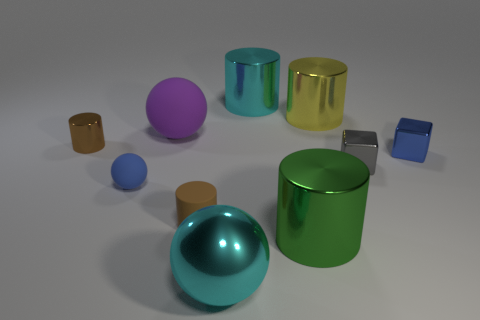What is the shape of the brown rubber object that is the same size as the blue rubber ball?
Give a very brief answer. Cylinder. Are there any brown things of the same shape as the big purple thing?
Give a very brief answer. No. What is the shape of the big thing left of the big cyan metallic object that is in front of the yellow metallic cylinder?
Your response must be concise. Sphere. What shape is the blue rubber thing?
Provide a succinct answer. Sphere. There is a large cyan object behind the metallic object that is in front of the large metallic cylinder that is in front of the big yellow cylinder; what is it made of?
Offer a terse response. Metal. What number of other objects are there of the same material as the small gray thing?
Give a very brief answer. 6. There is a large cyan thing in front of the large purple matte thing; how many gray shiny cubes are behind it?
Offer a very short reply. 1. How many spheres are brown matte objects or yellow metal things?
Provide a succinct answer. 0. What is the color of the large thing that is both to the right of the big cyan shiny sphere and in front of the yellow metallic object?
Keep it short and to the point. Green. Are there any other things of the same color as the large matte sphere?
Your answer should be compact. No. 